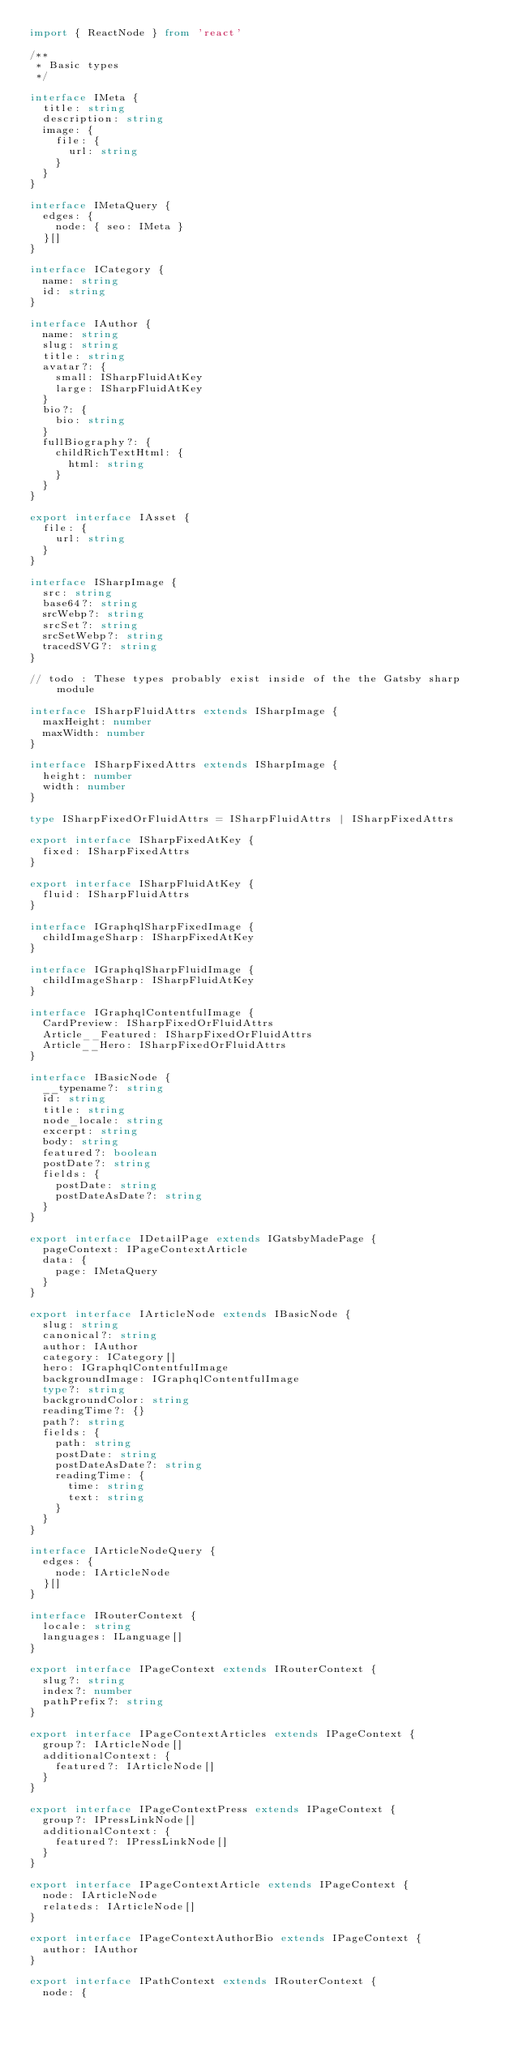<code> <loc_0><loc_0><loc_500><loc_500><_TypeScript_>import { ReactNode } from 'react'

/**
 * Basic types
 */

interface IMeta {
  title: string
  description: string
  image: {
    file: {
      url: string
    }
  }
}

interface IMetaQuery {
  edges: {
    node: { seo: IMeta }
  }[]
}

interface ICategory {
  name: string
  id: string
}

interface IAuthor {
  name: string
  slug: string
  title: string
  avatar?: {
    small: ISharpFluidAtKey
    large: ISharpFluidAtKey
  }
  bio?: {
    bio: string
  }
  fullBiography?: {
    childRichTextHtml: {
      html: string
    }
  }
}

export interface IAsset {
  file: {
    url: string
  }
}

interface ISharpImage {
  src: string
  base64?: string
  srcWebp?: string
  srcSet?: string
  srcSetWebp?: string
  tracedSVG?: string
}

// todo : These types probably exist inside of the the Gatsby sharp module

interface ISharpFluidAttrs extends ISharpImage {
  maxHeight: number
  maxWidth: number
}

interface ISharpFixedAttrs extends ISharpImage {
  height: number
  width: number
}

type ISharpFixedOrFluidAttrs = ISharpFluidAttrs | ISharpFixedAttrs

export interface ISharpFixedAtKey {
  fixed: ISharpFixedAttrs
}

export interface ISharpFluidAtKey {
  fluid: ISharpFluidAttrs
}

interface IGraphqlSharpFixedImage {
  childImageSharp: ISharpFixedAtKey
}

interface IGraphqlSharpFluidImage {
  childImageSharp: ISharpFluidAtKey
}

interface IGraphqlContentfulImage {
  CardPreview: ISharpFixedOrFluidAttrs
  Article__Featured: ISharpFixedOrFluidAttrs
  Article__Hero: ISharpFixedOrFluidAttrs
}

interface IBasicNode {
  __typename?: string
  id: string
  title: string
  node_locale: string
  excerpt: string
  body: string
  featured?: boolean
  postDate?: string
  fields: {
    postDate: string
    postDateAsDate?: string
  }
}

export interface IDetailPage extends IGatsbyMadePage {
  pageContext: IPageContextArticle
  data: {
    page: IMetaQuery
  }
}

export interface IArticleNode extends IBasicNode {
  slug: string
  canonical?: string
  author: IAuthor
  category: ICategory[]
  hero: IGraphqlContentfulImage
  backgroundImage: IGraphqlContentfulImage
  type?: string
  backgroundColor: string
  readingTime?: {}
  path?: string
  fields: {
    path: string
    postDate: string
    postDateAsDate?: string
    readingTime: {
      time: string
      text: string
    }
  }
}

interface IArticleNodeQuery {
  edges: {
    node: IArticleNode
  }[]
}

interface IRouterContext {
  locale: string
  languages: ILanguage[]
}

export interface IPageContext extends IRouterContext {
  slug?: string
  index?: number
  pathPrefix?: string
}

export interface IPageContextArticles extends IPageContext {
  group?: IArticleNode[]
  additionalContext: {
    featured?: IArticleNode[]
  }
}

export interface IPageContextPress extends IPageContext {
  group?: IPressLinkNode[]
  additionalContext: {
    featured?: IPressLinkNode[]
  }
}

export interface IPageContextArticle extends IPageContext {
  node: IArticleNode
  relateds: IArticleNode[]
}

export interface IPageContextAuthorBio extends IPageContext {
  author: IAuthor
}

export interface IPathContext extends IRouterContext {
  node: {</code> 